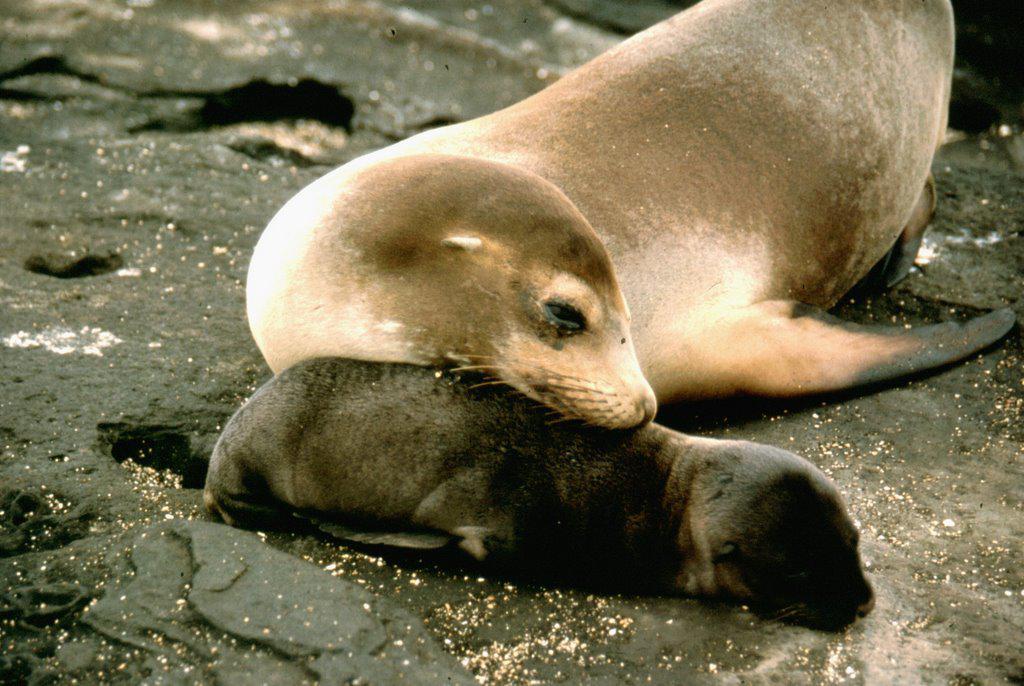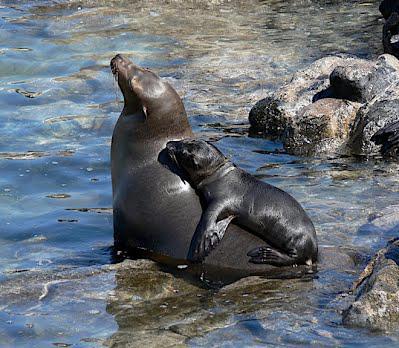The first image is the image on the left, the second image is the image on the right. Assess this claim about the two images: "There are no more than two seals.". Correct or not? Answer yes or no. No. The first image is the image on the left, the second image is the image on the right. For the images shown, is this caption "A tawny-colored seal is sleeping in at least one of the images." true? Answer yes or no. Yes. 